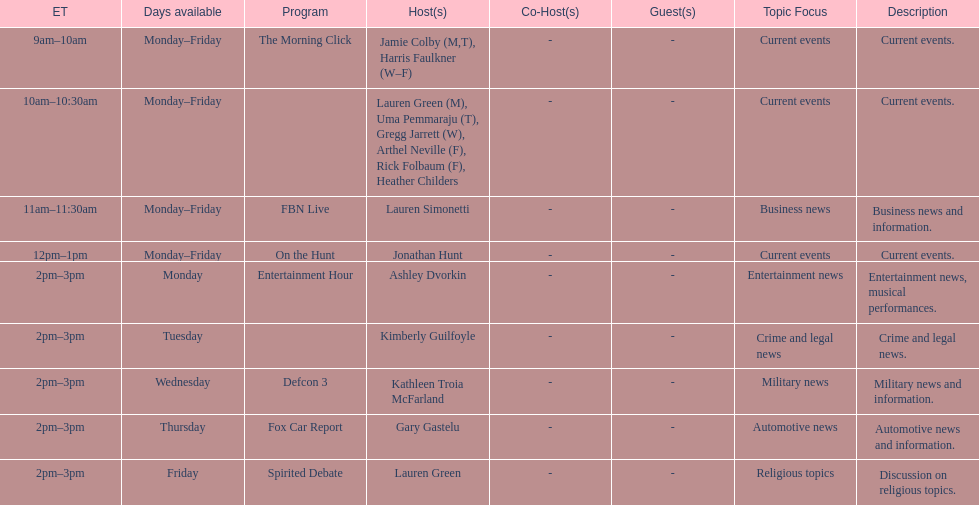How long does the show defcon 3 last? 1 hour. 